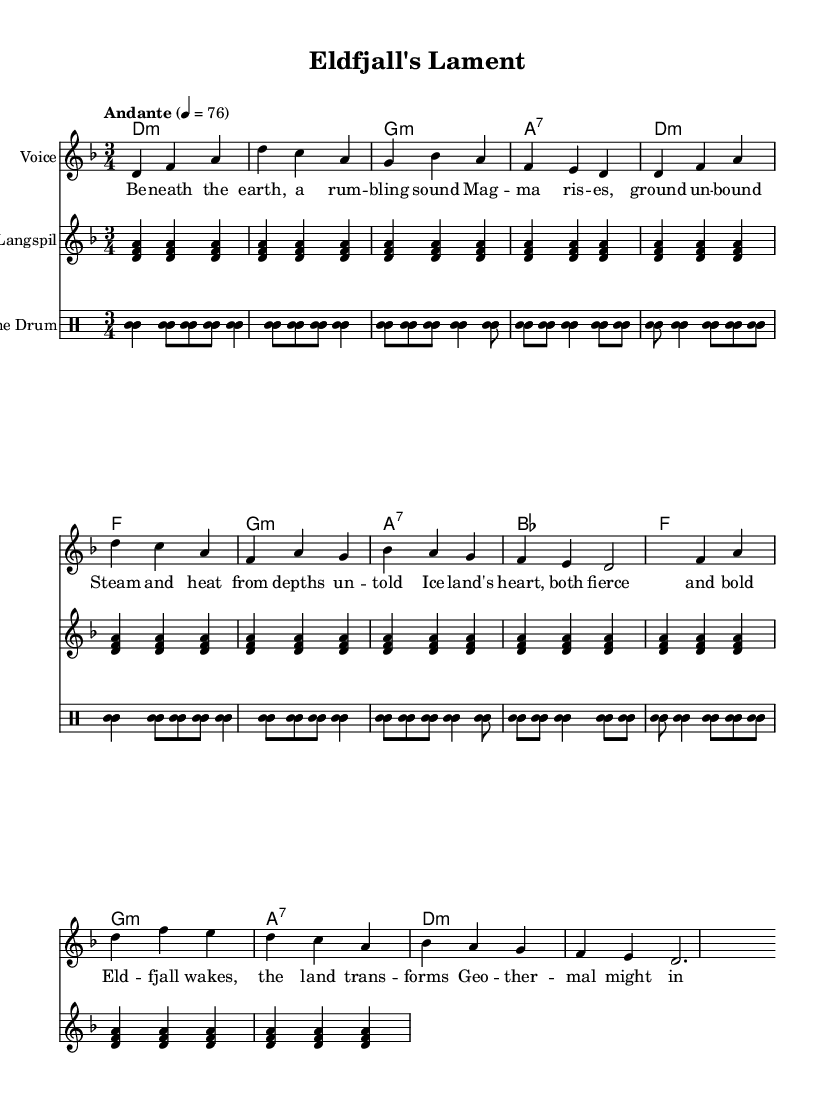What is the key signature of this music? The key signature is indicated at the beginning of the staff, showing two flat signs, which designates the key to be D minor.
Answer: D minor What is the time signature of this music? The time signature is shown in the first measure of the score, which is three quarter notes, indicating a 3/4 time signature.
Answer: 3/4 What is the tempo marking for this piece? The tempo marking appears directly above the staff, specifying the speed of the music to be "Andante," with a metronome marking of 76 beats per minute.
Answer: Andante, 76 How many measures are in the chorus? To find the number of measures, count the distinct segments marked in the chorus section of the music, which indicates there are four measures in total.
Answer: 4 What instruments are included in the score? The score consists of three different parts: a Voice part, a Langspil part, and a Frame Drum part, all of which are indicated at the beginning of their respective staves.
Answer: Voice, Langspil, Frame Drum Which part has lyrics written for it? The lyrics are specifically written below the Voice part, marked with "new Lyrics," which establishes that it accompanies the vocal melody.
Answer: Voice What theme is expressed in the lyrics of the song? Analyzing the lyrics reveals themes of volcanic activity, geothermal landscapes, and the power of nature, which are deeply rooted in Icelandic culture and folklore.
Answer: Volcanic activity and geothermal landscapes 